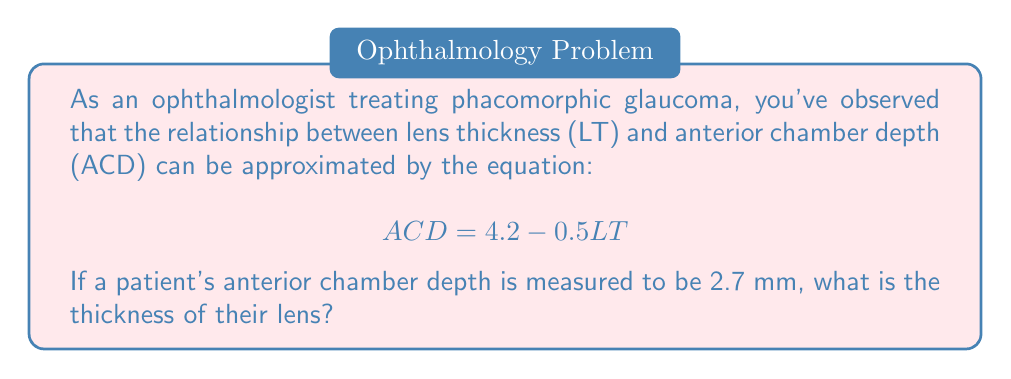Show me your answer to this math problem. To solve this problem, we need to use the given equation and substitute the known value for ACD. Then, we'll solve for the unknown variable LT (lens thickness).

1. Start with the given equation:
   $$ ACD = 4.2 - 0.5LT $$

2. Substitute the known value of ACD (2.7 mm):
   $$ 2.7 = 4.2 - 0.5LT $$

3. Subtract 4.2 from both sides to isolate the term with LT:
   $$ 2.7 - 4.2 = -0.5LT $$
   $$ -1.5 = -0.5LT $$

4. Divide both sides by -0.5 to solve for LT:
   $$ \frac{-1.5}{-0.5} = \frac{-0.5LT}{-0.5} $$
   $$ 3 = LT $$

Therefore, the lens thickness (LT) is 3 mm.
Answer: $LT = 3$ mm 